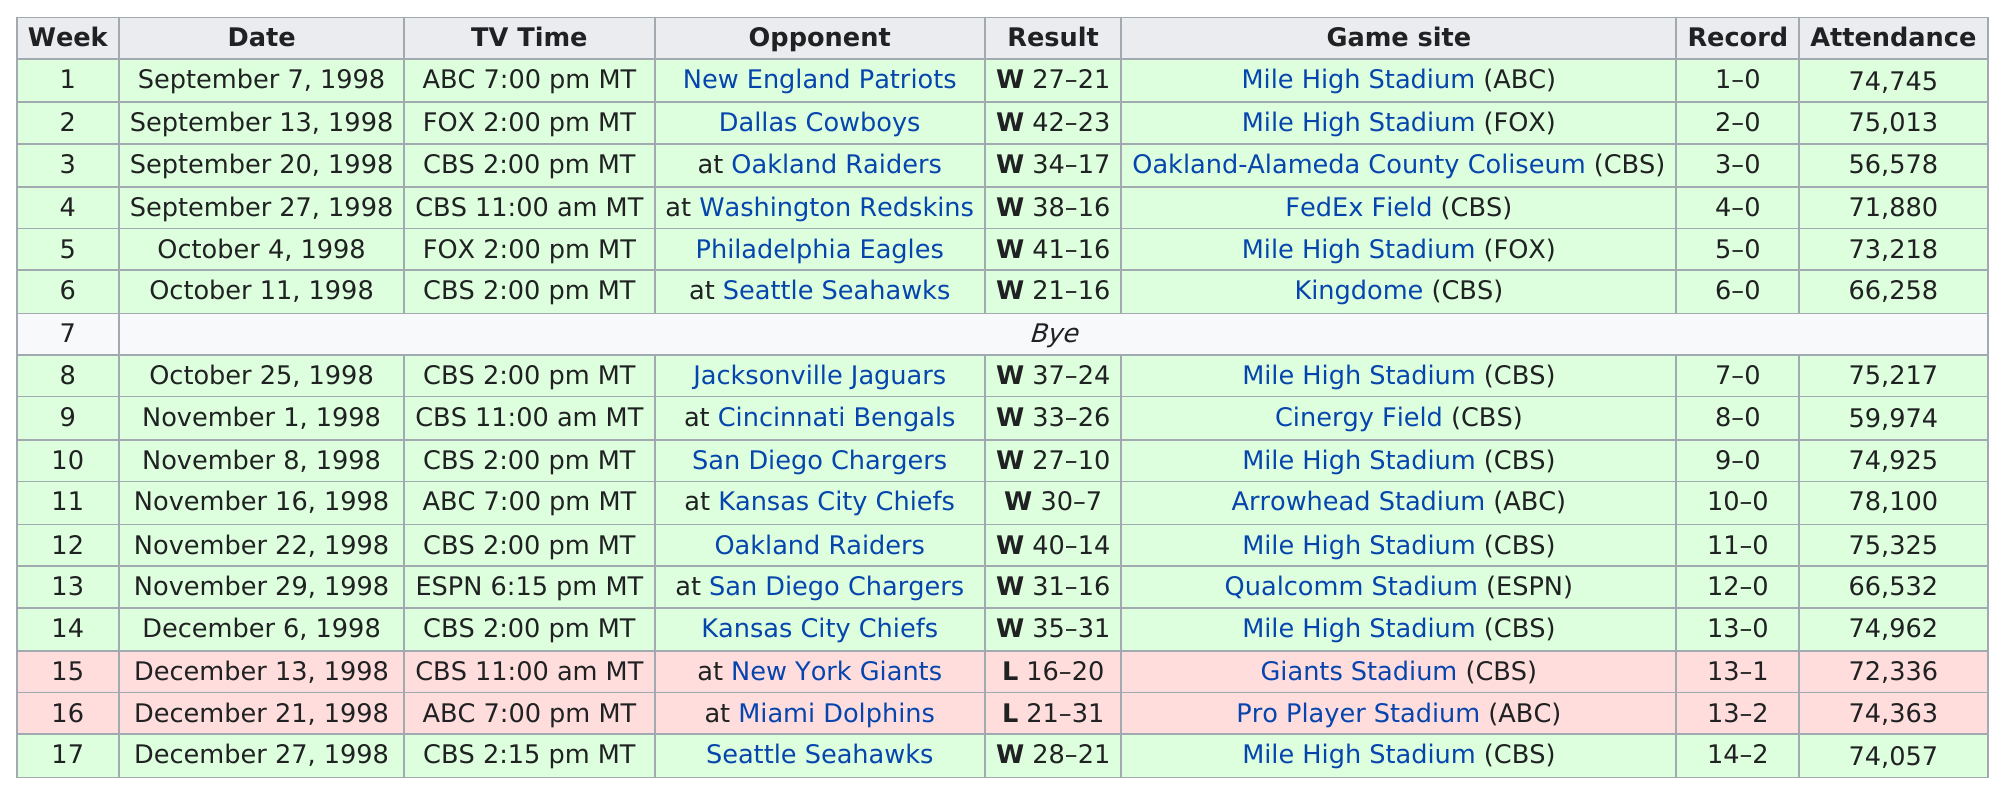Identify some key points in this picture. The attendance at the Broncos' most-attended game was significantly higher than the attendance at their least attended game, with a difference of 21,522 fans. The answer is: Weeks 1, 3, 4, 5, 6, 9, 10, 13, 14, 15, 16, 17 did not have more than 75,000 in attendance. In how many games did they score at least twice as many points as their opponent? In total, they scored at least twice as many points as their opponent in 6 games. The Denver Broncos game held on November 16, 1998, had the highest attendance record with the most number of people in attendance. The Denver Broncos won 13 consecutive games to start the 1998 season. 